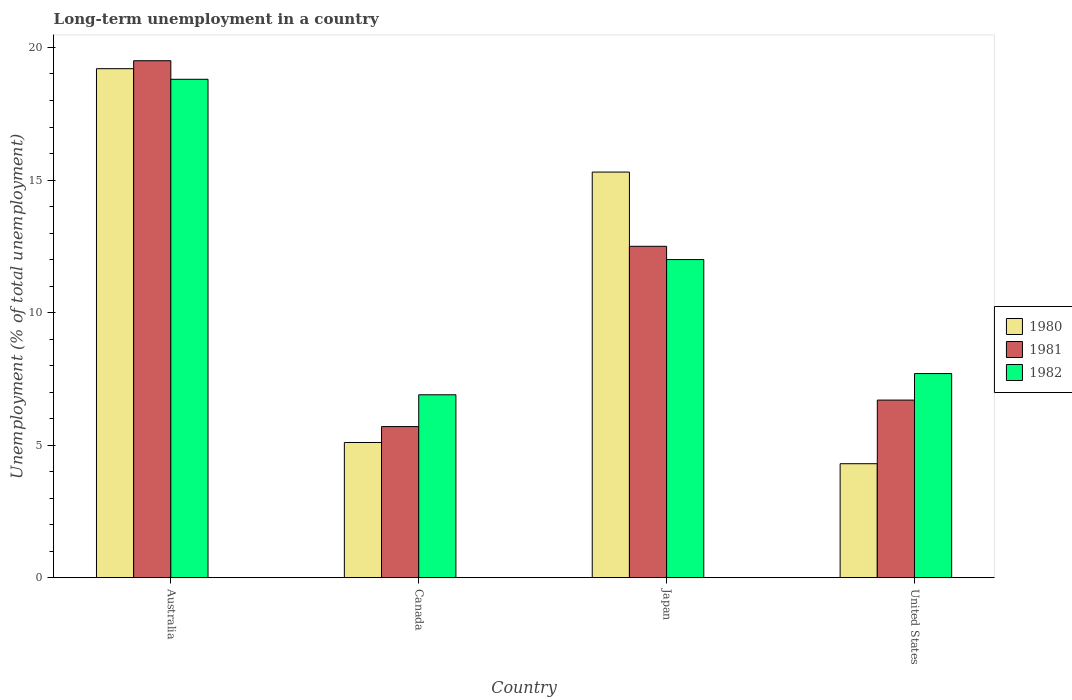How many different coloured bars are there?
Offer a very short reply. 3. How many groups of bars are there?
Your response must be concise. 4. What is the label of the 1st group of bars from the left?
Your answer should be very brief. Australia. In how many cases, is the number of bars for a given country not equal to the number of legend labels?
Provide a short and direct response. 0. Across all countries, what is the maximum percentage of long-term unemployed population in 1980?
Your answer should be compact. 19.2. Across all countries, what is the minimum percentage of long-term unemployed population in 1980?
Your answer should be compact. 4.3. What is the total percentage of long-term unemployed population in 1982 in the graph?
Your answer should be very brief. 45.4. What is the difference between the percentage of long-term unemployed population in 1981 in Canada and that in Japan?
Your answer should be very brief. -6.8. What is the difference between the percentage of long-term unemployed population in 1982 in Japan and the percentage of long-term unemployed population in 1980 in Australia?
Keep it short and to the point. -7.2. What is the average percentage of long-term unemployed population in 1982 per country?
Keep it short and to the point. 11.35. What is the difference between the percentage of long-term unemployed population of/in 1980 and percentage of long-term unemployed population of/in 1981 in Australia?
Offer a terse response. -0.3. In how many countries, is the percentage of long-term unemployed population in 1981 greater than 11 %?
Offer a very short reply. 2. What is the ratio of the percentage of long-term unemployed population in 1981 in Canada to that in United States?
Offer a terse response. 0.85. Is the difference between the percentage of long-term unemployed population in 1980 in Australia and Canada greater than the difference between the percentage of long-term unemployed population in 1981 in Australia and Canada?
Give a very brief answer. Yes. What is the difference between the highest and the lowest percentage of long-term unemployed population in 1980?
Offer a terse response. 14.9. Is the sum of the percentage of long-term unemployed population in 1982 in Australia and Canada greater than the maximum percentage of long-term unemployed population in 1981 across all countries?
Your answer should be compact. Yes. Is it the case that in every country, the sum of the percentage of long-term unemployed population in 1981 and percentage of long-term unemployed population in 1982 is greater than the percentage of long-term unemployed population in 1980?
Your response must be concise. Yes. Are the values on the major ticks of Y-axis written in scientific E-notation?
Your answer should be compact. No. Does the graph contain grids?
Your answer should be very brief. No. How many legend labels are there?
Make the answer very short. 3. How are the legend labels stacked?
Give a very brief answer. Vertical. What is the title of the graph?
Make the answer very short. Long-term unemployment in a country. Does "2009" appear as one of the legend labels in the graph?
Ensure brevity in your answer.  No. What is the label or title of the Y-axis?
Your answer should be very brief. Unemployment (% of total unemployment). What is the Unemployment (% of total unemployment) of 1980 in Australia?
Your answer should be compact. 19.2. What is the Unemployment (% of total unemployment) in 1981 in Australia?
Provide a short and direct response. 19.5. What is the Unemployment (% of total unemployment) in 1982 in Australia?
Make the answer very short. 18.8. What is the Unemployment (% of total unemployment) of 1980 in Canada?
Offer a very short reply. 5.1. What is the Unemployment (% of total unemployment) in 1981 in Canada?
Provide a succinct answer. 5.7. What is the Unemployment (% of total unemployment) in 1982 in Canada?
Ensure brevity in your answer.  6.9. What is the Unemployment (% of total unemployment) in 1980 in Japan?
Give a very brief answer. 15.3. What is the Unemployment (% of total unemployment) of 1982 in Japan?
Offer a terse response. 12. What is the Unemployment (% of total unemployment) of 1980 in United States?
Your answer should be compact. 4.3. What is the Unemployment (% of total unemployment) of 1981 in United States?
Make the answer very short. 6.7. What is the Unemployment (% of total unemployment) of 1982 in United States?
Ensure brevity in your answer.  7.7. Across all countries, what is the maximum Unemployment (% of total unemployment) of 1980?
Provide a succinct answer. 19.2. Across all countries, what is the maximum Unemployment (% of total unemployment) in 1982?
Provide a short and direct response. 18.8. Across all countries, what is the minimum Unemployment (% of total unemployment) of 1980?
Your answer should be compact. 4.3. Across all countries, what is the minimum Unemployment (% of total unemployment) of 1981?
Keep it short and to the point. 5.7. Across all countries, what is the minimum Unemployment (% of total unemployment) of 1982?
Your answer should be very brief. 6.9. What is the total Unemployment (% of total unemployment) in 1980 in the graph?
Provide a short and direct response. 43.9. What is the total Unemployment (% of total unemployment) in 1981 in the graph?
Give a very brief answer. 44.4. What is the total Unemployment (% of total unemployment) in 1982 in the graph?
Your answer should be very brief. 45.4. What is the difference between the Unemployment (% of total unemployment) in 1980 in Australia and that in Canada?
Make the answer very short. 14.1. What is the difference between the Unemployment (% of total unemployment) of 1981 in Australia and that in Japan?
Your response must be concise. 7. What is the difference between the Unemployment (% of total unemployment) of 1982 in Australia and that in Japan?
Your answer should be compact. 6.8. What is the difference between the Unemployment (% of total unemployment) in 1982 in Australia and that in United States?
Your answer should be very brief. 11.1. What is the difference between the Unemployment (% of total unemployment) in 1980 in Canada and that in Japan?
Your response must be concise. -10.2. What is the difference between the Unemployment (% of total unemployment) in 1982 in Canada and that in Japan?
Provide a short and direct response. -5.1. What is the difference between the Unemployment (% of total unemployment) of 1980 in Canada and that in United States?
Provide a short and direct response. 0.8. What is the difference between the Unemployment (% of total unemployment) of 1981 in Canada and that in United States?
Make the answer very short. -1. What is the difference between the Unemployment (% of total unemployment) in 1980 in Japan and that in United States?
Provide a succinct answer. 11. What is the difference between the Unemployment (% of total unemployment) in 1981 in Australia and the Unemployment (% of total unemployment) in 1982 in Canada?
Offer a terse response. 12.6. What is the difference between the Unemployment (% of total unemployment) of 1980 in Australia and the Unemployment (% of total unemployment) of 1982 in Japan?
Your answer should be compact. 7.2. What is the difference between the Unemployment (% of total unemployment) in 1980 in Australia and the Unemployment (% of total unemployment) in 1982 in United States?
Keep it short and to the point. 11.5. What is the difference between the Unemployment (% of total unemployment) of 1981 in Australia and the Unemployment (% of total unemployment) of 1982 in United States?
Keep it short and to the point. 11.8. What is the difference between the Unemployment (% of total unemployment) of 1980 in Canada and the Unemployment (% of total unemployment) of 1982 in United States?
Offer a very short reply. -2.6. What is the difference between the Unemployment (% of total unemployment) in 1981 in Canada and the Unemployment (% of total unemployment) in 1982 in United States?
Ensure brevity in your answer.  -2. What is the difference between the Unemployment (% of total unemployment) in 1980 in Japan and the Unemployment (% of total unemployment) in 1981 in United States?
Give a very brief answer. 8.6. What is the average Unemployment (% of total unemployment) of 1980 per country?
Give a very brief answer. 10.97. What is the average Unemployment (% of total unemployment) in 1982 per country?
Give a very brief answer. 11.35. What is the difference between the Unemployment (% of total unemployment) of 1980 and Unemployment (% of total unemployment) of 1982 in Australia?
Your response must be concise. 0.4. What is the difference between the Unemployment (% of total unemployment) in 1981 and Unemployment (% of total unemployment) in 1982 in Australia?
Offer a terse response. 0.7. What is the difference between the Unemployment (% of total unemployment) of 1980 and Unemployment (% of total unemployment) of 1982 in Canada?
Offer a very short reply. -1.8. What is the difference between the Unemployment (% of total unemployment) of 1980 and Unemployment (% of total unemployment) of 1982 in Japan?
Your answer should be very brief. 3.3. What is the ratio of the Unemployment (% of total unemployment) in 1980 in Australia to that in Canada?
Your answer should be compact. 3.76. What is the ratio of the Unemployment (% of total unemployment) in 1981 in Australia to that in Canada?
Offer a very short reply. 3.42. What is the ratio of the Unemployment (% of total unemployment) of 1982 in Australia to that in Canada?
Offer a very short reply. 2.72. What is the ratio of the Unemployment (% of total unemployment) of 1980 in Australia to that in Japan?
Your answer should be compact. 1.25. What is the ratio of the Unemployment (% of total unemployment) of 1981 in Australia to that in Japan?
Your answer should be compact. 1.56. What is the ratio of the Unemployment (% of total unemployment) of 1982 in Australia to that in Japan?
Give a very brief answer. 1.57. What is the ratio of the Unemployment (% of total unemployment) in 1980 in Australia to that in United States?
Offer a very short reply. 4.47. What is the ratio of the Unemployment (% of total unemployment) of 1981 in Australia to that in United States?
Provide a succinct answer. 2.91. What is the ratio of the Unemployment (% of total unemployment) of 1982 in Australia to that in United States?
Provide a short and direct response. 2.44. What is the ratio of the Unemployment (% of total unemployment) of 1980 in Canada to that in Japan?
Provide a short and direct response. 0.33. What is the ratio of the Unemployment (% of total unemployment) in 1981 in Canada to that in Japan?
Offer a very short reply. 0.46. What is the ratio of the Unemployment (% of total unemployment) of 1982 in Canada to that in Japan?
Provide a succinct answer. 0.57. What is the ratio of the Unemployment (% of total unemployment) in 1980 in Canada to that in United States?
Make the answer very short. 1.19. What is the ratio of the Unemployment (% of total unemployment) in 1981 in Canada to that in United States?
Your answer should be compact. 0.85. What is the ratio of the Unemployment (% of total unemployment) in 1982 in Canada to that in United States?
Give a very brief answer. 0.9. What is the ratio of the Unemployment (% of total unemployment) of 1980 in Japan to that in United States?
Your answer should be compact. 3.56. What is the ratio of the Unemployment (% of total unemployment) in 1981 in Japan to that in United States?
Ensure brevity in your answer.  1.87. What is the ratio of the Unemployment (% of total unemployment) of 1982 in Japan to that in United States?
Provide a short and direct response. 1.56. What is the difference between the highest and the second highest Unemployment (% of total unemployment) of 1980?
Your answer should be compact. 3.9. What is the difference between the highest and the second highest Unemployment (% of total unemployment) of 1981?
Your answer should be very brief. 7. What is the difference between the highest and the second highest Unemployment (% of total unemployment) of 1982?
Your response must be concise. 6.8. 